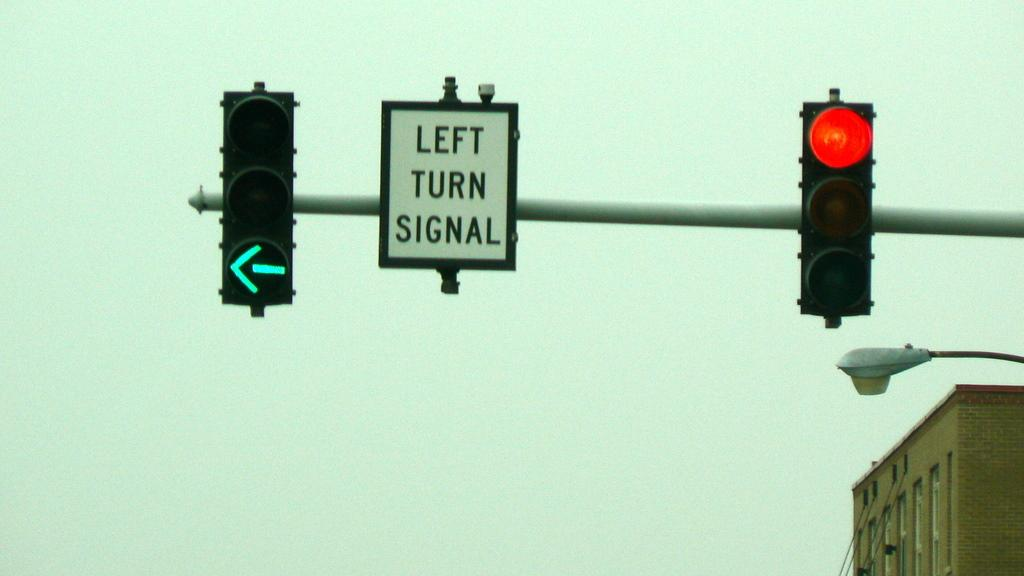<image>
Share a concise interpretation of the image provided. a left turn signal that is next to the lights 